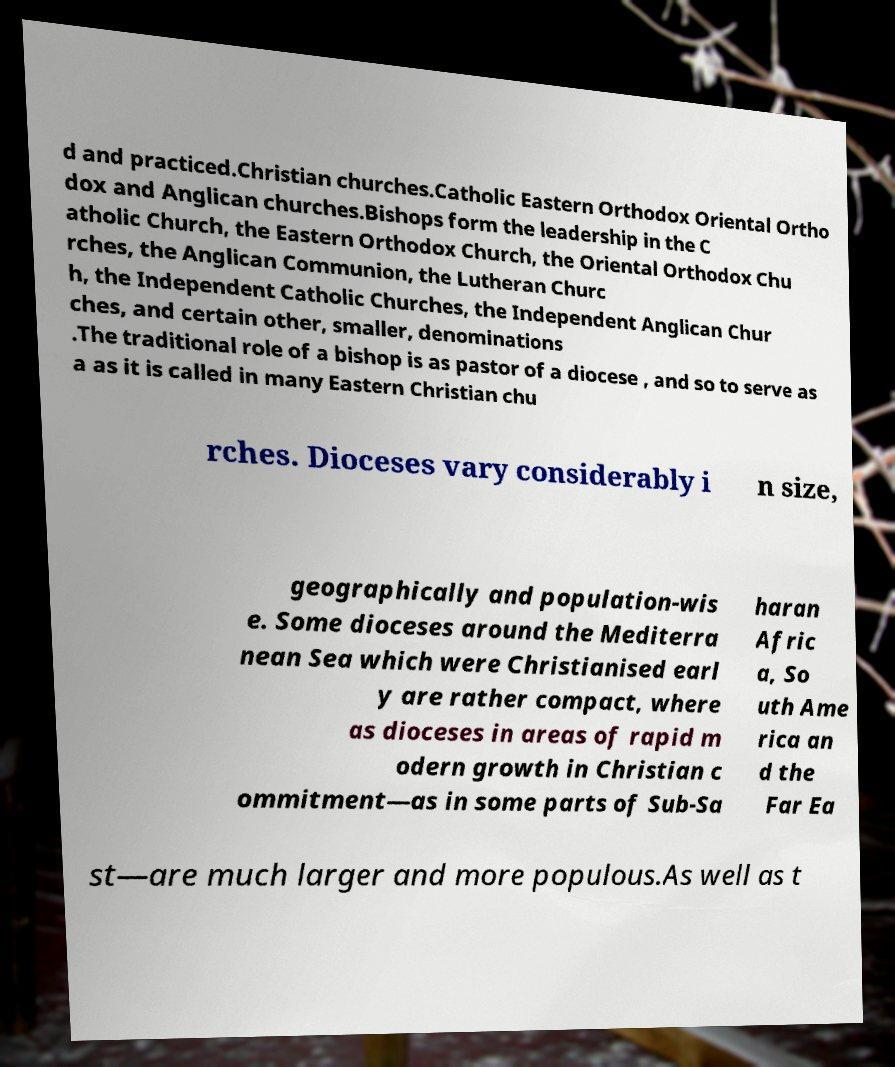Can you read and provide the text displayed in the image?This photo seems to have some interesting text. Can you extract and type it out for me? d and practiced.Christian churches.Catholic Eastern Orthodox Oriental Ortho dox and Anglican churches.Bishops form the leadership in the C atholic Church, the Eastern Orthodox Church, the Oriental Orthodox Chu rches, the Anglican Communion, the Lutheran Churc h, the Independent Catholic Churches, the Independent Anglican Chur ches, and certain other, smaller, denominations .The traditional role of a bishop is as pastor of a diocese , and so to serve as a as it is called in many Eastern Christian chu rches. Dioceses vary considerably i n size, geographically and population-wis e. Some dioceses around the Mediterra nean Sea which were Christianised earl y are rather compact, where as dioceses in areas of rapid m odern growth in Christian c ommitment—as in some parts of Sub-Sa haran Afric a, So uth Ame rica an d the Far Ea st—are much larger and more populous.As well as t 